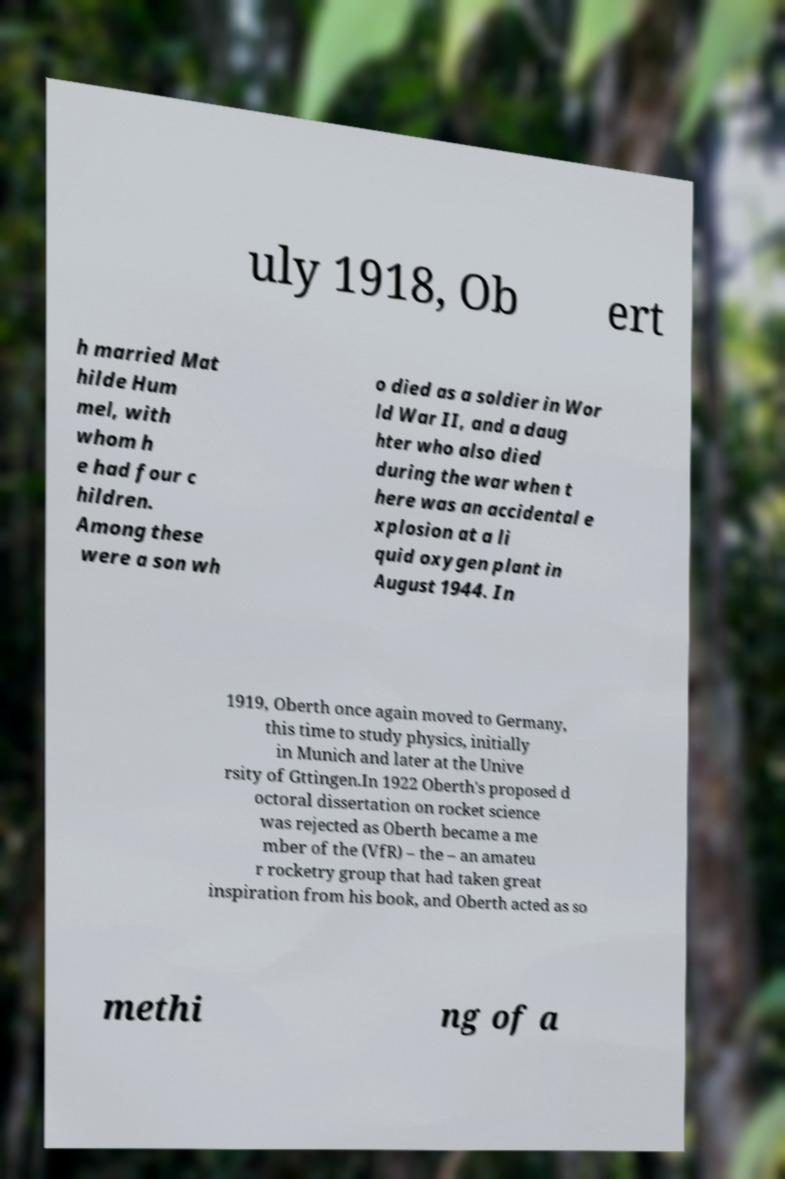Can you accurately transcribe the text from the provided image for me? uly 1918, Ob ert h married Mat hilde Hum mel, with whom h e had four c hildren. Among these were a son wh o died as a soldier in Wor ld War II, and a daug hter who also died during the war when t here was an accidental e xplosion at a li quid oxygen plant in August 1944. In 1919, Oberth once again moved to Germany, this time to study physics, initially in Munich and later at the Unive rsity of Gttingen.In 1922 Oberth's proposed d octoral dissertation on rocket science was rejected as Oberth became a me mber of the (VfR) – the – an amateu r rocketry group that had taken great inspiration from his book, and Oberth acted as so methi ng of a 